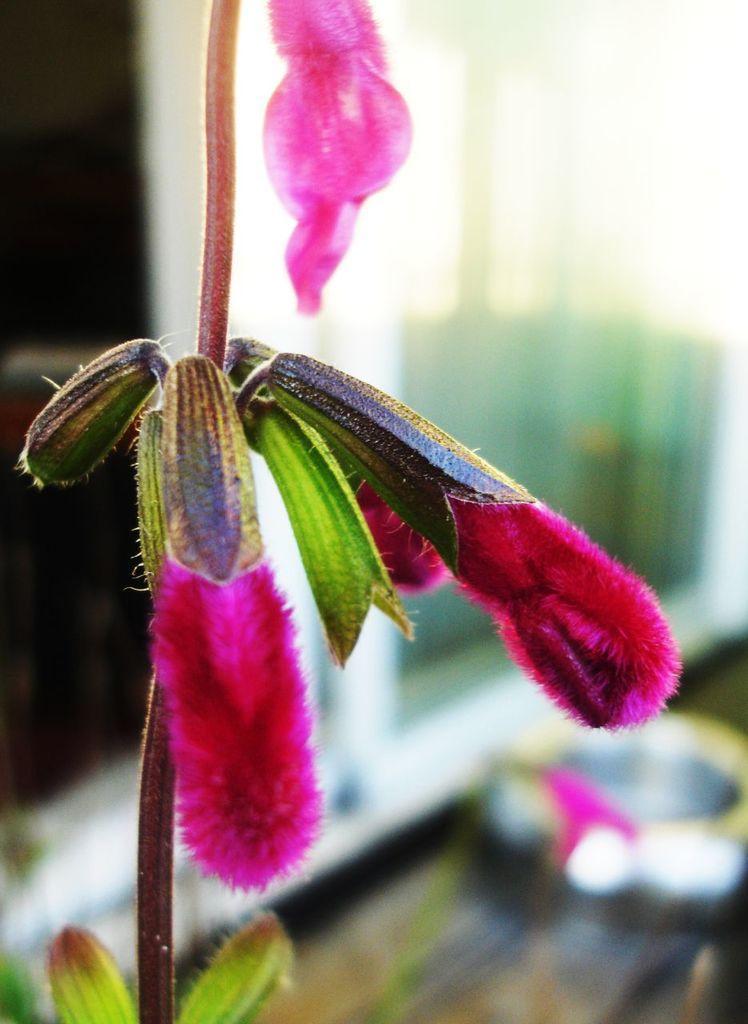In one or two sentences, can you explain what this image depicts? In this image we can see plant with pink flowers. In the background the image is blur but we can see the objects. 